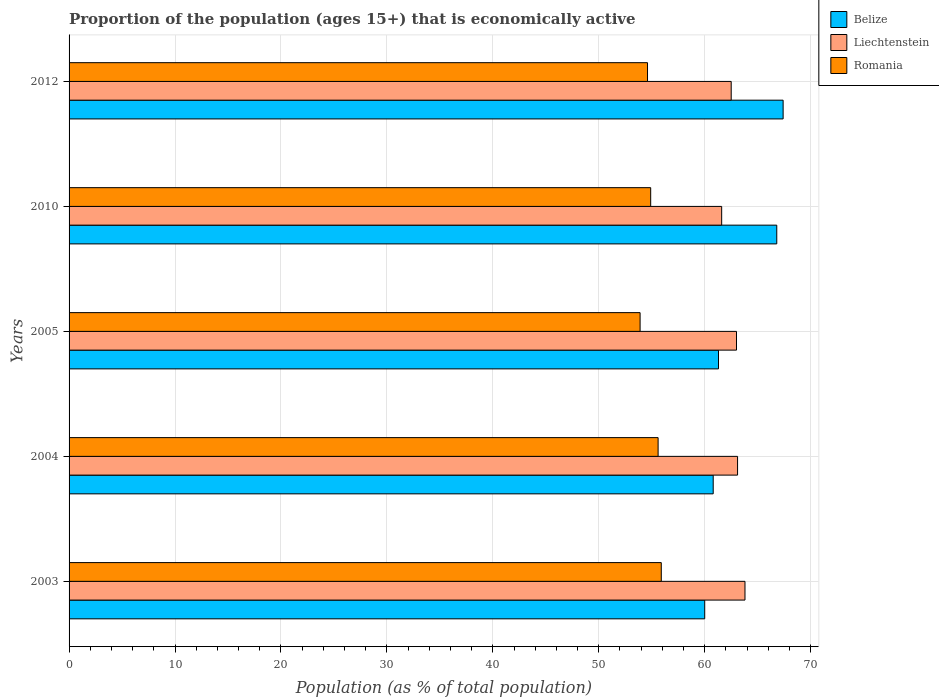Are the number of bars per tick equal to the number of legend labels?
Make the answer very short. Yes. Are the number of bars on each tick of the Y-axis equal?
Keep it short and to the point. Yes. How many bars are there on the 3rd tick from the top?
Ensure brevity in your answer.  3. How many bars are there on the 4th tick from the bottom?
Provide a short and direct response. 3. Across all years, what is the maximum proportion of the population that is economically active in Belize?
Keep it short and to the point. 67.4. Across all years, what is the minimum proportion of the population that is economically active in Romania?
Your response must be concise. 53.9. In which year was the proportion of the population that is economically active in Belize maximum?
Offer a very short reply. 2012. What is the total proportion of the population that is economically active in Romania in the graph?
Offer a terse response. 274.9. What is the difference between the proportion of the population that is economically active in Liechtenstein in 2005 and that in 2010?
Your answer should be compact. 1.4. What is the difference between the proportion of the population that is economically active in Belize in 2005 and the proportion of the population that is economically active in Romania in 2012?
Provide a succinct answer. 6.7. What is the average proportion of the population that is economically active in Liechtenstein per year?
Your answer should be very brief. 62.8. In the year 2003, what is the difference between the proportion of the population that is economically active in Liechtenstein and proportion of the population that is economically active in Romania?
Your answer should be compact. 7.9. In how many years, is the proportion of the population that is economically active in Romania greater than 6 %?
Your answer should be very brief. 5. What is the ratio of the proportion of the population that is economically active in Liechtenstein in 2010 to that in 2012?
Offer a very short reply. 0.99. Is the proportion of the population that is economically active in Liechtenstein in 2003 less than that in 2004?
Offer a terse response. No. What is the difference between the highest and the second highest proportion of the population that is economically active in Romania?
Provide a succinct answer. 0.3. What is the difference between the highest and the lowest proportion of the population that is economically active in Belize?
Give a very brief answer. 7.4. Is the sum of the proportion of the population that is economically active in Romania in 2005 and 2012 greater than the maximum proportion of the population that is economically active in Liechtenstein across all years?
Ensure brevity in your answer.  Yes. What does the 3rd bar from the top in 2003 represents?
Provide a succinct answer. Belize. What does the 1st bar from the bottom in 2003 represents?
Offer a terse response. Belize. How many bars are there?
Your answer should be very brief. 15. Are all the bars in the graph horizontal?
Offer a very short reply. Yes. How many years are there in the graph?
Offer a very short reply. 5. What is the difference between two consecutive major ticks on the X-axis?
Offer a very short reply. 10. Does the graph contain any zero values?
Your response must be concise. No. Does the graph contain grids?
Give a very brief answer. Yes. Where does the legend appear in the graph?
Give a very brief answer. Top right. What is the title of the graph?
Ensure brevity in your answer.  Proportion of the population (ages 15+) that is economically active. Does "Lao PDR" appear as one of the legend labels in the graph?
Offer a terse response. No. What is the label or title of the X-axis?
Give a very brief answer. Population (as % of total population). What is the Population (as % of total population) in Belize in 2003?
Keep it short and to the point. 60. What is the Population (as % of total population) of Liechtenstein in 2003?
Your answer should be compact. 63.8. What is the Population (as % of total population) of Romania in 2003?
Provide a short and direct response. 55.9. What is the Population (as % of total population) in Belize in 2004?
Your response must be concise. 60.8. What is the Population (as % of total population) in Liechtenstein in 2004?
Make the answer very short. 63.1. What is the Population (as % of total population) of Romania in 2004?
Offer a very short reply. 55.6. What is the Population (as % of total population) of Belize in 2005?
Your answer should be compact. 61.3. What is the Population (as % of total population) of Romania in 2005?
Keep it short and to the point. 53.9. What is the Population (as % of total population) in Belize in 2010?
Your answer should be very brief. 66.8. What is the Population (as % of total population) in Liechtenstein in 2010?
Make the answer very short. 61.6. What is the Population (as % of total population) in Romania in 2010?
Keep it short and to the point. 54.9. What is the Population (as % of total population) in Belize in 2012?
Offer a very short reply. 67.4. What is the Population (as % of total population) in Liechtenstein in 2012?
Ensure brevity in your answer.  62.5. What is the Population (as % of total population) of Romania in 2012?
Make the answer very short. 54.6. Across all years, what is the maximum Population (as % of total population) in Belize?
Your answer should be compact. 67.4. Across all years, what is the maximum Population (as % of total population) of Liechtenstein?
Offer a terse response. 63.8. Across all years, what is the maximum Population (as % of total population) of Romania?
Keep it short and to the point. 55.9. Across all years, what is the minimum Population (as % of total population) of Liechtenstein?
Make the answer very short. 61.6. Across all years, what is the minimum Population (as % of total population) of Romania?
Provide a short and direct response. 53.9. What is the total Population (as % of total population) of Belize in the graph?
Make the answer very short. 316.3. What is the total Population (as % of total population) in Liechtenstein in the graph?
Your answer should be compact. 314. What is the total Population (as % of total population) in Romania in the graph?
Your answer should be compact. 274.9. What is the difference between the Population (as % of total population) of Liechtenstein in 2003 and that in 2004?
Ensure brevity in your answer.  0.7. What is the difference between the Population (as % of total population) of Belize in 2003 and that in 2005?
Your answer should be very brief. -1.3. What is the difference between the Population (as % of total population) of Liechtenstein in 2003 and that in 2005?
Offer a terse response. 0.8. What is the difference between the Population (as % of total population) of Romania in 2003 and that in 2005?
Make the answer very short. 2. What is the difference between the Population (as % of total population) of Belize in 2003 and that in 2010?
Offer a terse response. -6.8. What is the difference between the Population (as % of total population) of Liechtenstein in 2003 and that in 2012?
Keep it short and to the point. 1.3. What is the difference between the Population (as % of total population) of Belize in 2004 and that in 2005?
Offer a terse response. -0.5. What is the difference between the Population (as % of total population) in Liechtenstein in 2004 and that in 2005?
Ensure brevity in your answer.  0.1. What is the difference between the Population (as % of total population) in Romania in 2004 and that in 2005?
Offer a terse response. 1.7. What is the difference between the Population (as % of total population) in Belize in 2004 and that in 2012?
Give a very brief answer. -6.6. What is the difference between the Population (as % of total population) in Liechtenstein in 2005 and that in 2010?
Your response must be concise. 1.4. What is the difference between the Population (as % of total population) in Liechtenstein in 2005 and that in 2012?
Ensure brevity in your answer.  0.5. What is the difference between the Population (as % of total population) of Belize in 2010 and that in 2012?
Offer a very short reply. -0.6. What is the difference between the Population (as % of total population) of Liechtenstein in 2010 and that in 2012?
Your response must be concise. -0.9. What is the difference between the Population (as % of total population) in Belize in 2003 and the Population (as % of total population) in Romania in 2004?
Ensure brevity in your answer.  4.4. What is the difference between the Population (as % of total population) of Belize in 2003 and the Population (as % of total population) of Romania in 2010?
Your answer should be very brief. 5.1. What is the difference between the Population (as % of total population) in Liechtenstein in 2003 and the Population (as % of total population) in Romania in 2012?
Provide a succinct answer. 9.2. What is the difference between the Population (as % of total population) of Belize in 2004 and the Population (as % of total population) of Liechtenstein in 2005?
Your answer should be compact. -2.2. What is the difference between the Population (as % of total population) in Belize in 2004 and the Population (as % of total population) in Romania in 2005?
Provide a short and direct response. 6.9. What is the difference between the Population (as % of total population) in Liechtenstein in 2004 and the Population (as % of total population) in Romania in 2010?
Keep it short and to the point. 8.2. What is the difference between the Population (as % of total population) in Belize in 2004 and the Population (as % of total population) in Liechtenstein in 2012?
Give a very brief answer. -1.7. What is the difference between the Population (as % of total population) in Belize in 2004 and the Population (as % of total population) in Romania in 2012?
Give a very brief answer. 6.2. What is the difference between the Population (as % of total population) in Belize in 2005 and the Population (as % of total population) in Liechtenstein in 2010?
Your answer should be compact. -0.3. What is the difference between the Population (as % of total population) of Belize in 2005 and the Population (as % of total population) of Romania in 2010?
Keep it short and to the point. 6.4. What is the difference between the Population (as % of total population) in Liechtenstein in 2005 and the Population (as % of total population) in Romania in 2010?
Offer a very short reply. 8.1. What is the difference between the Population (as % of total population) in Belize in 2005 and the Population (as % of total population) in Liechtenstein in 2012?
Make the answer very short. -1.2. What is the difference between the Population (as % of total population) of Liechtenstein in 2005 and the Population (as % of total population) of Romania in 2012?
Provide a succinct answer. 8.4. What is the difference between the Population (as % of total population) in Belize in 2010 and the Population (as % of total population) in Romania in 2012?
Make the answer very short. 12.2. What is the difference between the Population (as % of total population) of Liechtenstein in 2010 and the Population (as % of total population) of Romania in 2012?
Provide a succinct answer. 7. What is the average Population (as % of total population) of Belize per year?
Your response must be concise. 63.26. What is the average Population (as % of total population) in Liechtenstein per year?
Your response must be concise. 62.8. What is the average Population (as % of total population) of Romania per year?
Give a very brief answer. 54.98. In the year 2003, what is the difference between the Population (as % of total population) of Belize and Population (as % of total population) of Liechtenstein?
Make the answer very short. -3.8. In the year 2003, what is the difference between the Population (as % of total population) in Liechtenstein and Population (as % of total population) in Romania?
Make the answer very short. 7.9. In the year 2004, what is the difference between the Population (as % of total population) in Belize and Population (as % of total population) in Romania?
Your response must be concise. 5.2. In the year 2004, what is the difference between the Population (as % of total population) in Liechtenstein and Population (as % of total population) in Romania?
Offer a very short reply. 7.5. In the year 2005, what is the difference between the Population (as % of total population) of Belize and Population (as % of total population) of Romania?
Your response must be concise. 7.4. In the year 2010, what is the difference between the Population (as % of total population) of Belize and Population (as % of total population) of Liechtenstein?
Your answer should be very brief. 5.2. What is the ratio of the Population (as % of total population) in Belize in 2003 to that in 2004?
Make the answer very short. 0.99. What is the ratio of the Population (as % of total population) of Liechtenstein in 2003 to that in 2004?
Your response must be concise. 1.01. What is the ratio of the Population (as % of total population) in Romania in 2003 to that in 2004?
Provide a succinct answer. 1.01. What is the ratio of the Population (as % of total population) in Belize in 2003 to that in 2005?
Provide a succinct answer. 0.98. What is the ratio of the Population (as % of total population) of Liechtenstein in 2003 to that in 2005?
Your answer should be very brief. 1.01. What is the ratio of the Population (as % of total population) of Romania in 2003 to that in 2005?
Make the answer very short. 1.04. What is the ratio of the Population (as % of total population) of Belize in 2003 to that in 2010?
Offer a very short reply. 0.9. What is the ratio of the Population (as % of total population) of Liechtenstein in 2003 to that in 2010?
Provide a succinct answer. 1.04. What is the ratio of the Population (as % of total population) in Romania in 2003 to that in 2010?
Provide a short and direct response. 1.02. What is the ratio of the Population (as % of total population) in Belize in 2003 to that in 2012?
Offer a very short reply. 0.89. What is the ratio of the Population (as % of total population) in Liechtenstein in 2003 to that in 2012?
Your answer should be very brief. 1.02. What is the ratio of the Population (as % of total population) in Romania in 2003 to that in 2012?
Your answer should be very brief. 1.02. What is the ratio of the Population (as % of total population) of Romania in 2004 to that in 2005?
Keep it short and to the point. 1.03. What is the ratio of the Population (as % of total population) in Belize in 2004 to that in 2010?
Your answer should be compact. 0.91. What is the ratio of the Population (as % of total population) in Liechtenstein in 2004 to that in 2010?
Your answer should be compact. 1.02. What is the ratio of the Population (as % of total population) of Romania in 2004 to that in 2010?
Your answer should be compact. 1.01. What is the ratio of the Population (as % of total population) of Belize in 2004 to that in 2012?
Your answer should be compact. 0.9. What is the ratio of the Population (as % of total population) in Liechtenstein in 2004 to that in 2012?
Offer a terse response. 1.01. What is the ratio of the Population (as % of total population) in Romania in 2004 to that in 2012?
Ensure brevity in your answer.  1.02. What is the ratio of the Population (as % of total population) of Belize in 2005 to that in 2010?
Provide a short and direct response. 0.92. What is the ratio of the Population (as % of total population) in Liechtenstein in 2005 to that in 2010?
Offer a terse response. 1.02. What is the ratio of the Population (as % of total population) in Romania in 2005 to that in 2010?
Give a very brief answer. 0.98. What is the ratio of the Population (as % of total population) of Belize in 2005 to that in 2012?
Provide a succinct answer. 0.91. What is the ratio of the Population (as % of total population) in Liechtenstein in 2005 to that in 2012?
Offer a terse response. 1.01. What is the ratio of the Population (as % of total population) in Romania in 2005 to that in 2012?
Your answer should be very brief. 0.99. What is the ratio of the Population (as % of total population) of Belize in 2010 to that in 2012?
Keep it short and to the point. 0.99. What is the ratio of the Population (as % of total population) in Liechtenstein in 2010 to that in 2012?
Keep it short and to the point. 0.99. What is the ratio of the Population (as % of total population) of Romania in 2010 to that in 2012?
Your answer should be compact. 1.01. What is the difference between the highest and the second highest Population (as % of total population) of Liechtenstein?
Your response must be concise. 0.7. What is the difference between the highest and the lowest Population (as % of total population) of Belize?
Provide a short and direct response. 7.4. 